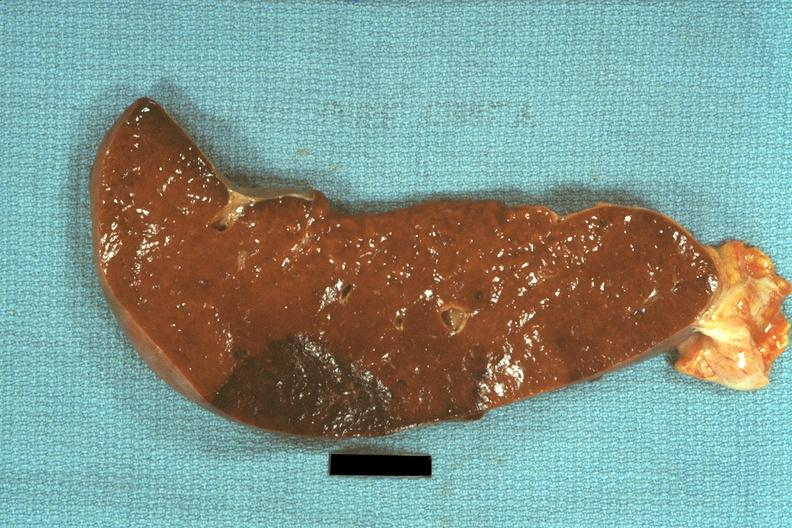does this image show typical dark infarct?
Answer the question using a single word or phrase. Yes 